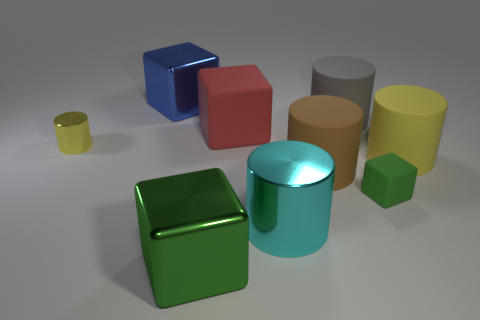What material is the cyan cylinder that is the same size as the blue thing?
Your answer should be compact. Metal. Does the yellow thing that is to the left of the red object have the same shape as the brown object to the left of the large gray matte cylinder?
Your answer should be compact. Yes. What is the shape of the other thing that is the same size as the green rubber object?
Your response must be concise. Cylinder. Are the big cylinder in front of the brown rubber object and the tiny yellow object that is in front of the big blue shiny cube made of the same material?
Ensure brevity in your answer.  Yes. There is a cylinder in front of the brown matte cylinder; is there a big metallic object on the left side of it?
Offer a very short reply. Yes. What is the color of the small block that is the same material as the large yellow cylinder?
Your answer should be very brief. Green. Is the number of small yellow objects greater than the number of purple metal things?
Give a very brief answer. Yes. What number of objects are yellow cylinders on the left side of the brown rubber thing or gray rubber blocks?
Your answer should be very brief. 1. Is there a blue shiny block of the same size as the brown rubber thing?
Offer a very short reply. Yes. Are there fewer small metallic things than cyan rubber things?
Ensure brevity in your answer.  No. 